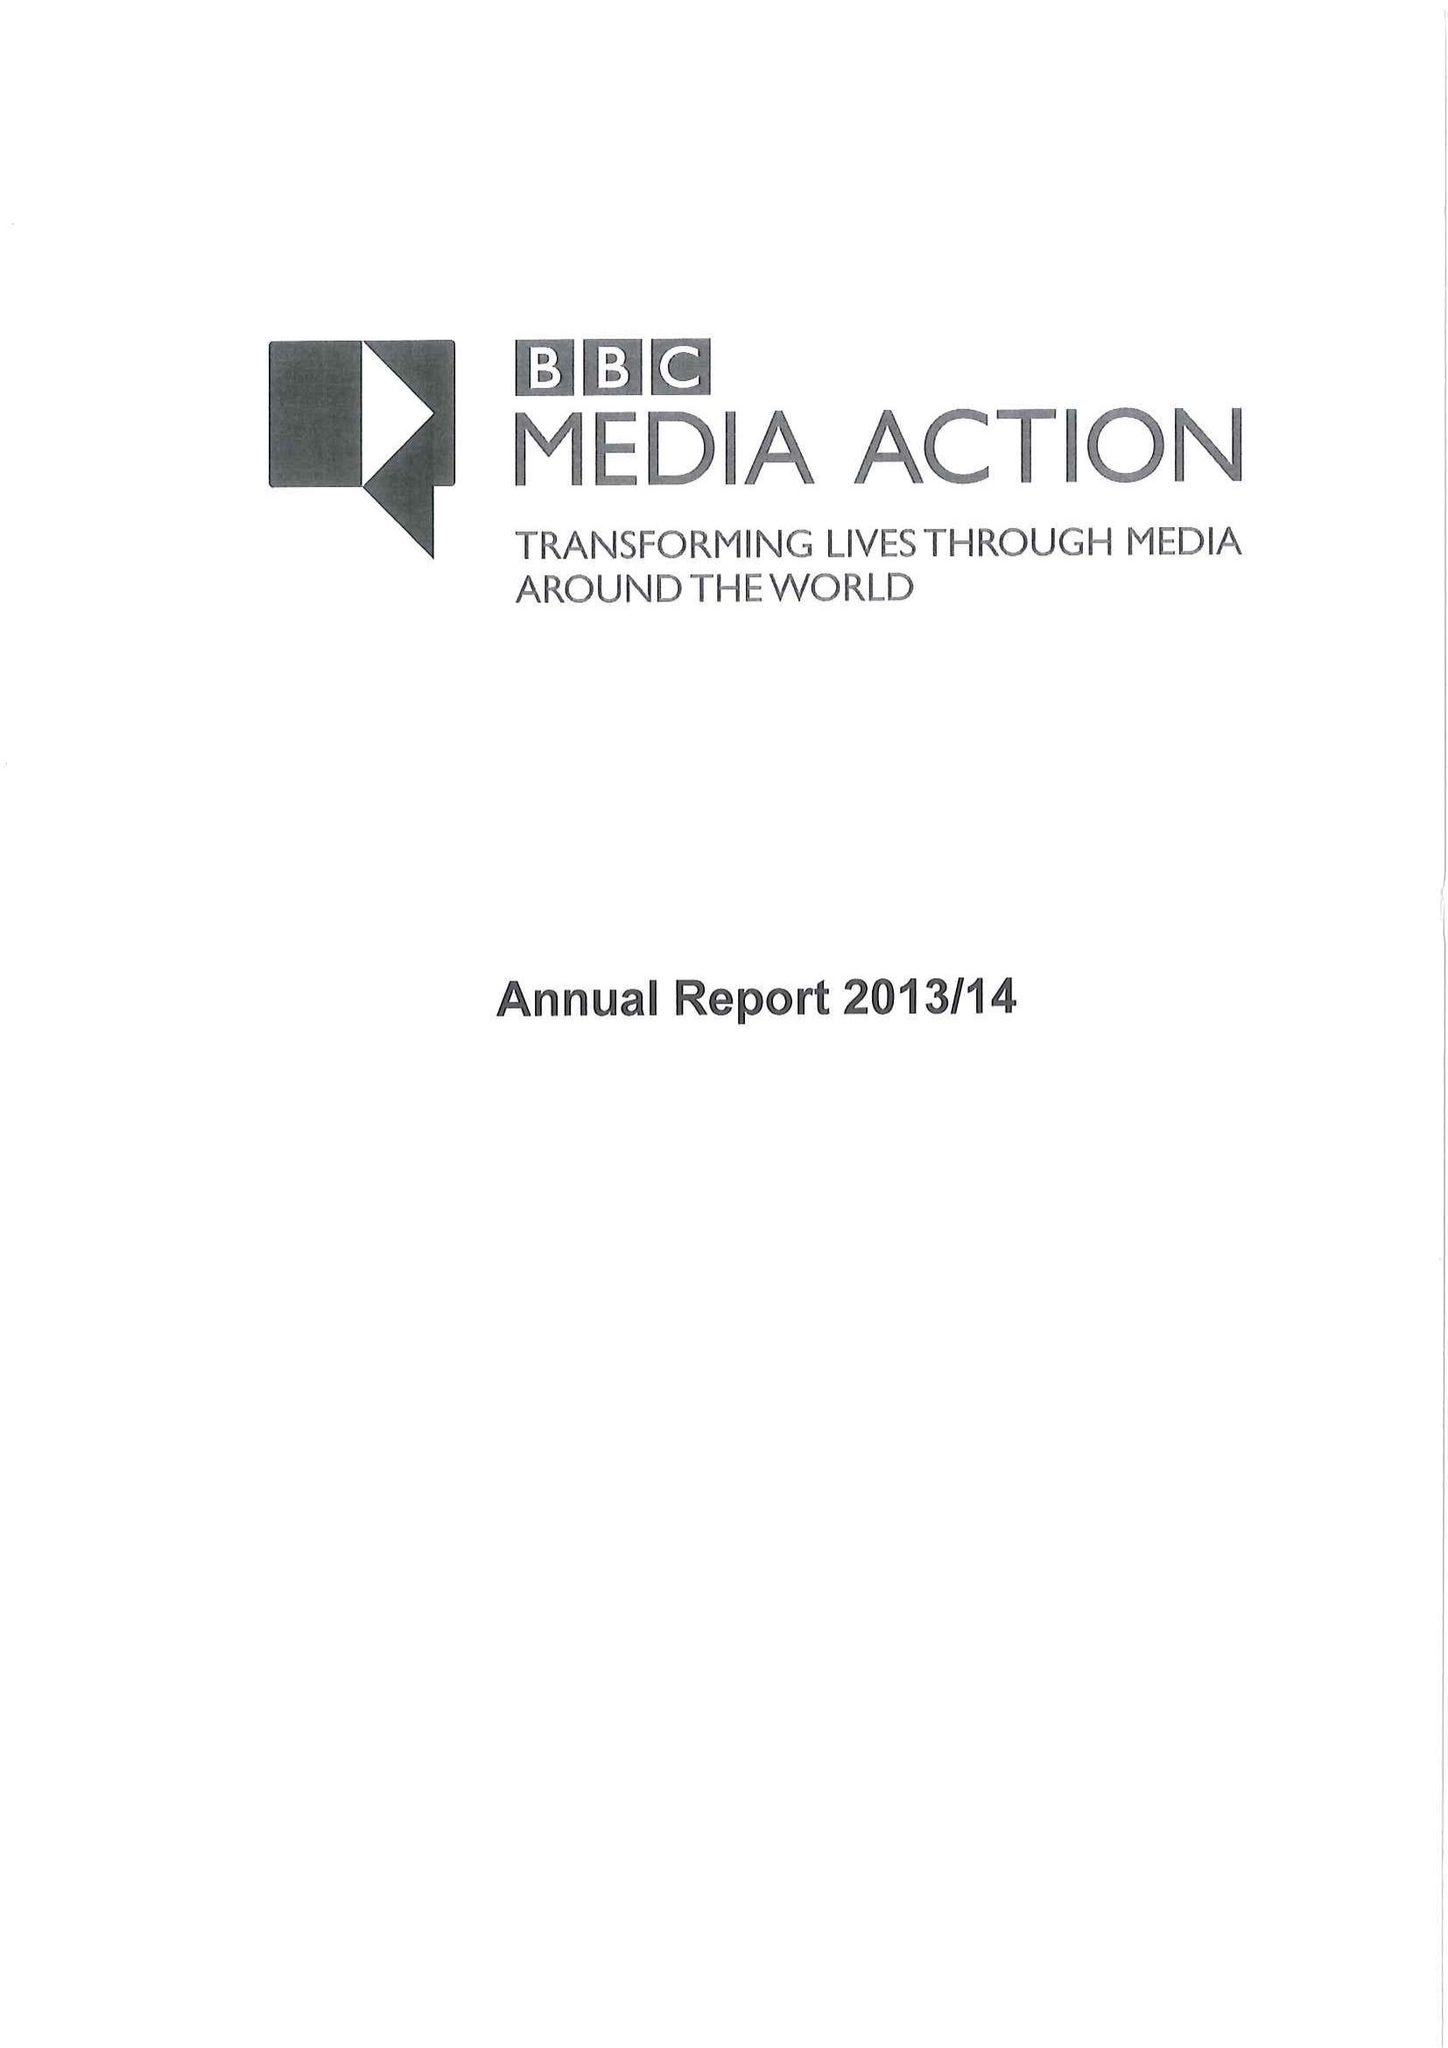What is the value for the address__street_line?
Answer the question using a single word or phrase. PORTLAND PLACE 